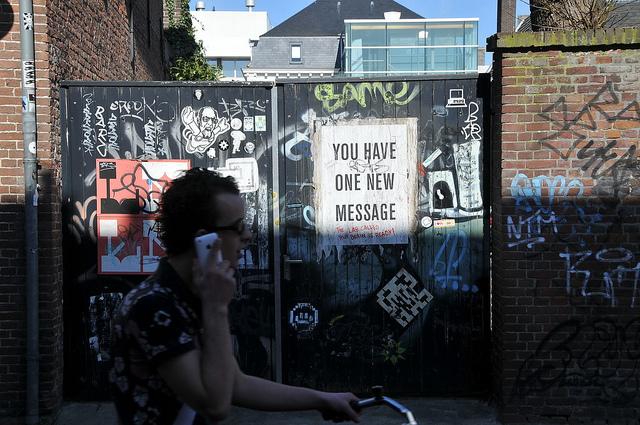The signs says "You have one new?
Concise answer only. Message. Is there a painting on the wall?
Be succinct. Yes. What is the guy doing?
Keep it brief. Talking on phone. 